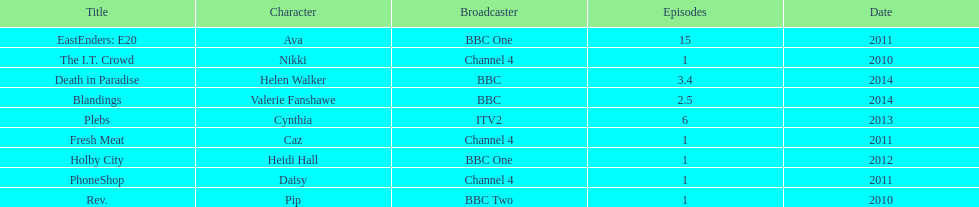What was the previous role this actress played before playing cynthia in plebs? Heidi Hall. 